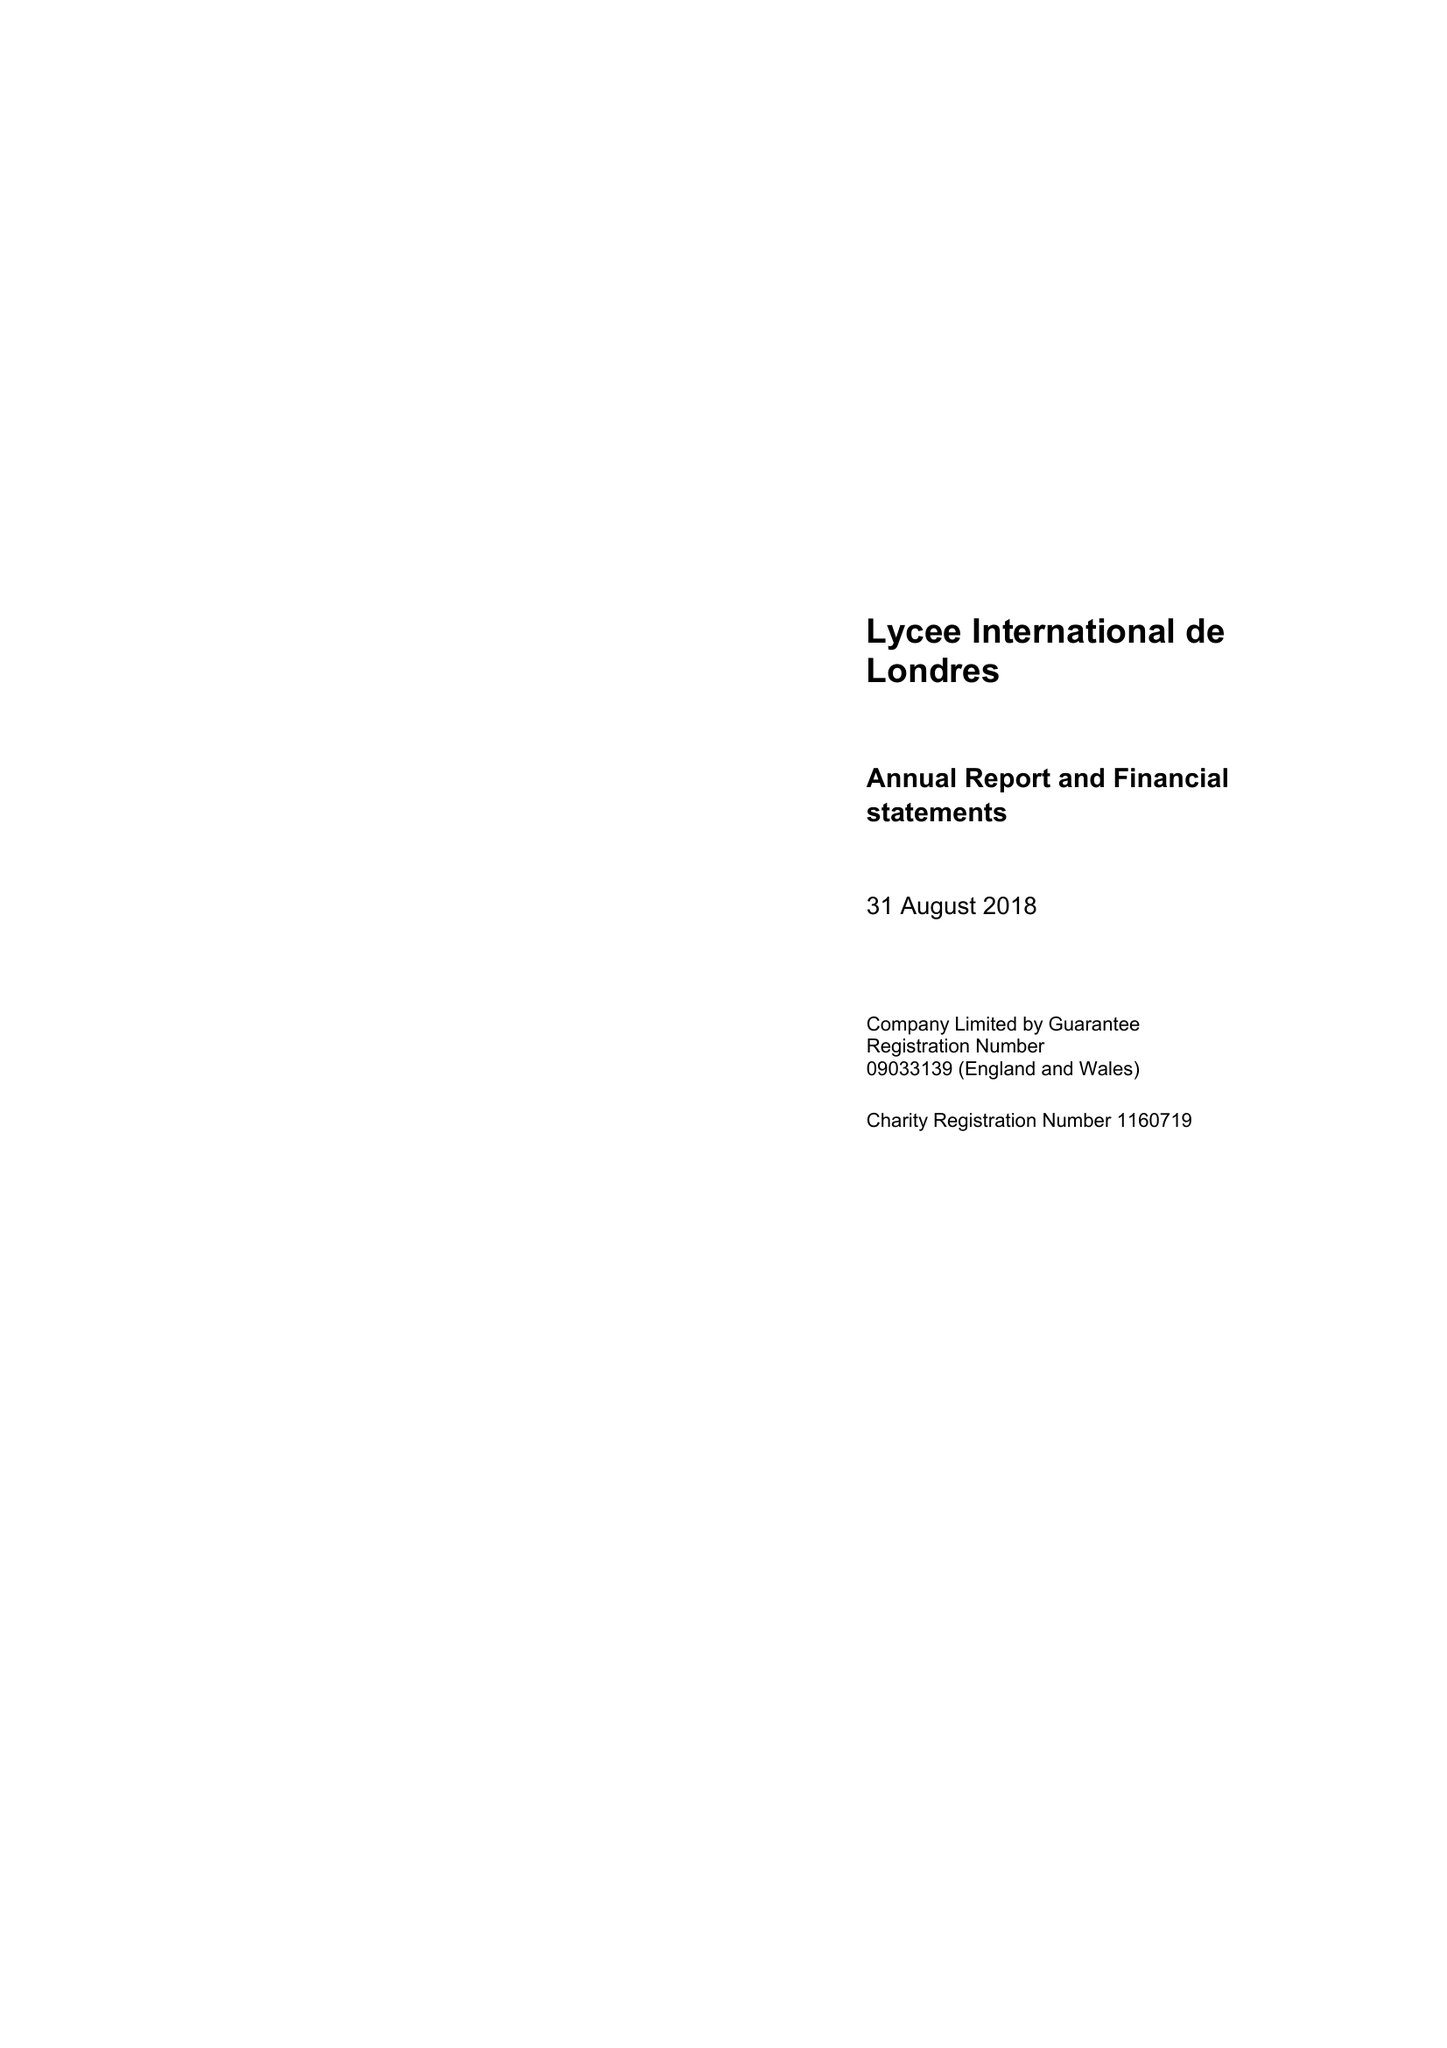What is the value for the report_date?
Answer the question using a single word or phrase. 2018-08-31 